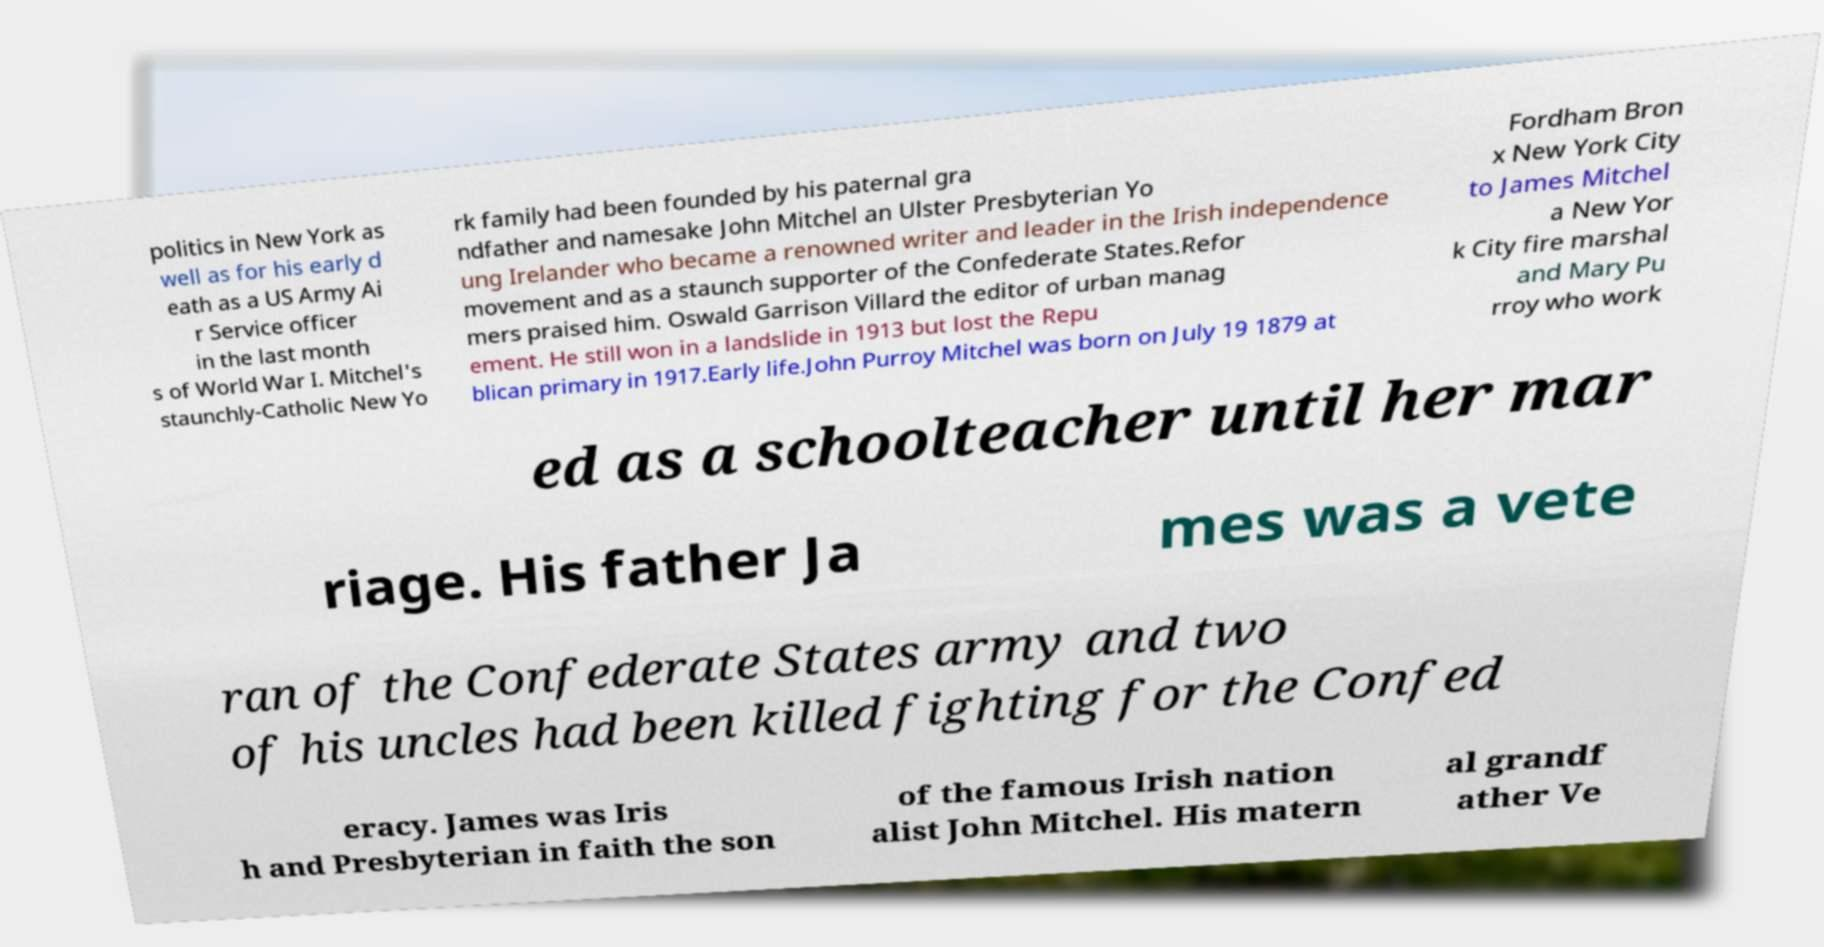For documentation purposes, I need the text within this image transcribed. Could you provide that? politics in New York as well as for his early d eath as a US Army Ai r Service officer in the last month s of World War I. Mitchel's staunchly-Catholic New Yo rk family had been founded by his paternal gra ndfather and namesake John Mitchel an Ulster Presbyterian Yo ung Irelander who became a renowned writer and leader in the Irish independence movement and as a staunch supporter of the Confederate States.Refor mers praised him. Oswald Garrison Villard the editor of urban manag ement. He still won in a landslide in 1913 but lost the Repu blican primary in 1917.Early life.John Purroy Mitchel was born on July 19 1879 at Fordham Bron x New York City to James Mitchel a New Yor k City fire marshal and Mary Pu rroy who work ed as a schoolteacher until her mar riage. His father Ja mes was a vete ran of the Confederate States army and two of his uncles had been killed fighting for the Confed eracy. James was Iris h and Presbyterian in faith the son of the famous Irish nation alist John Mitchel. His matern al grandf ather Ve 